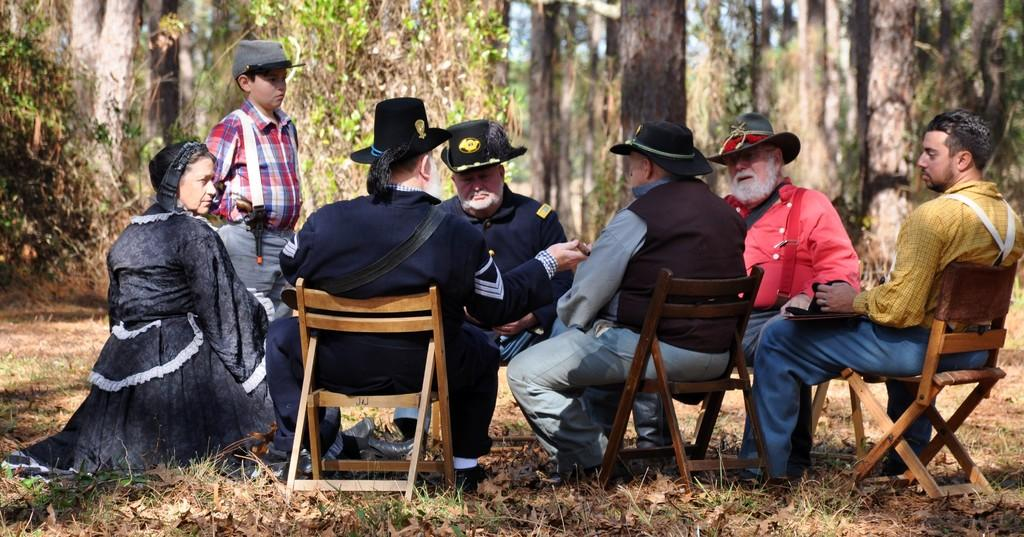What are the people in the image doing? A: The people in the image are sitting on chairs. What are the people wearing on their heads? The people are wearing hats. What is the child in the image doing? The child is standing in front of the people. What can be seen in the background of the image? There are trees and the sky visible in the background of the image. What type of fruit is being stretched by the rays of the sun in the image? There is no fruit or rays of the sun present in the image. 